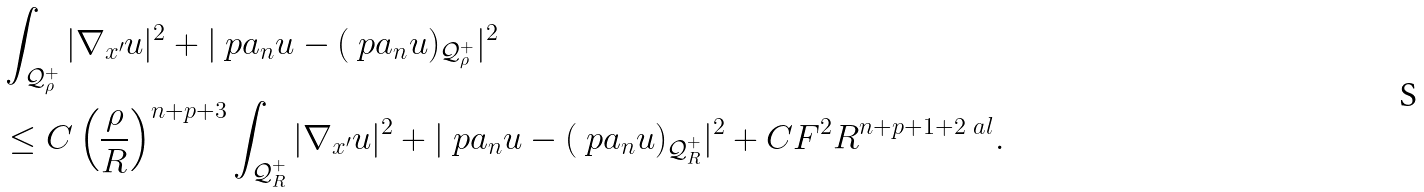<formula> <loc_0><loc_0><loc_500><loc_500>& \int _ { \mathcal { Q } _ { \rho } ^ { + } } | \nabla _ { x ^ { \prime } } u | ^ { 2 } + | \ p a _ { n } u - ( \ p a _ { n } u ) _ { \mathcal { Q } _ { \rho } ^ { + } } | ^ { 2 } \\ & \leq C \left ( \frac { \rho } { R } \right ) ^ { n + p + 3 } \int _ { \mathcal { Q } _ { R } ^ { + } } | \nabla _ { x ^ { \prime } } u | ^ { 2 } + | \ p a _ { n } u - ( \ p a _ { n } u ) _ { \mathcal { Q } _ { R } ^ { + } } | ^ { 2 } + C F ^ { 2 } R ^ { n + p + 1 + 2 \ a l } .</formula> 